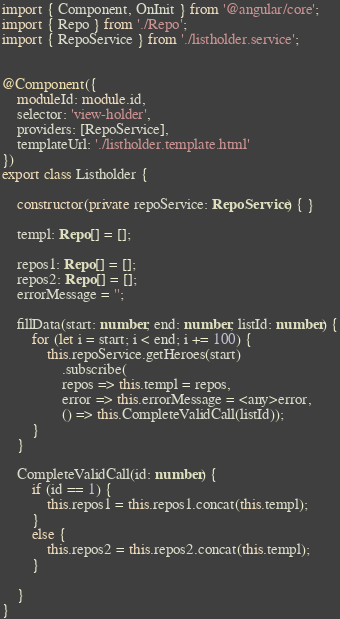Convert code to text. <code><loc_0><loc_0><loc_500><loc_500><_TypeScript_>import { Component, OnInit } from '@angular/core';
import { Repo } from './Repo';
import { RepoService } from './listholder.service';


@Component({
    moduleId: module.id,
    selector: 'view-holder',
    providers: [RepoService],
    templateUrl: './listholder.template.html'
})
export class Listholder {

    constructor(private repoService: RepoService) { }

    templ: Repo[] = [];

    repos1: Repo[] = [];
    repos2: Repo[] = [];
    errorMessage = '';

    fillData(start: number, end: number, listId: number) {
        for (let i = start; i < end; i += 100) {
            this.repoService.getHeroes(start)
                .subscribe(
                repos => this.templ = repos,
                error => this.errorMessage = <any>error,
                () => this.CompleteValidCall(listId));
        }
    }

    CompleteValidCall(id: number) {
        if (id == 1) {
            this.repos1 = this.repos1.concat(this.templ);
        }
        else {
            this.repos2 = this.repos2.concat(this.templ);
        }

    }
}
</code> 